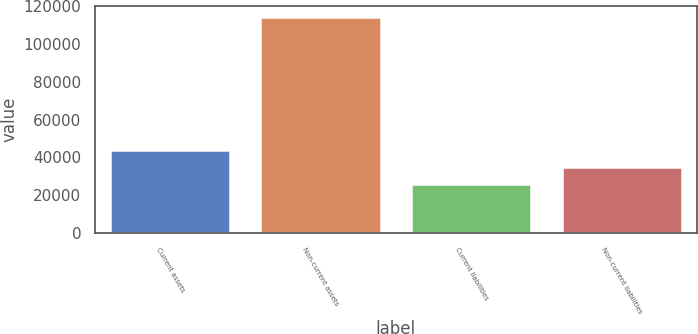Convert chart to OTSL. <chart><loc_0><loc_0><loc_500><loc_500><bar_chart><fcel>Current assets<fcel>Non-current assets<fcel>Current liabilities<fcel>Non-current liabilities<nl><fcel>43669<fcel>114397<fcel>25987<fcel>34828<nl></chart> 